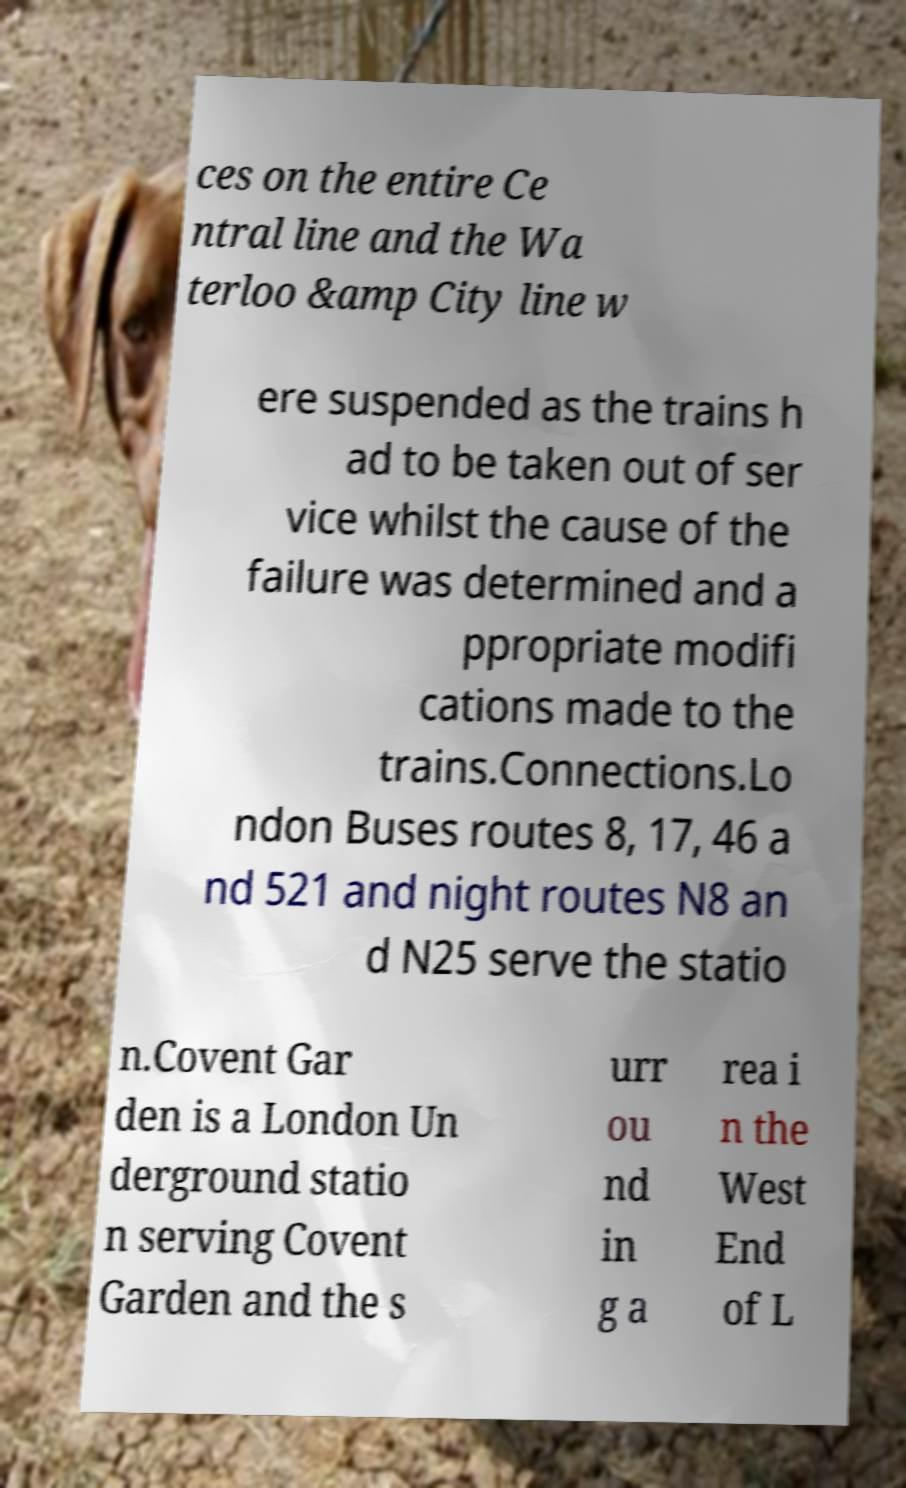Can you accurately transcribe the text from the provided image for me? ces on the entire Ce ntral line and the Wa terloo &amp City line w ere suspended as the trains h ad to be taken out of ser vice whilst the cause of the failure was determined and a ppropriate modifi cations made to the trains.Connections.Lo ndon Buses routes 8, 17, 46 a nd 521 and night routes N8 an d N25 serve the statio n.Covent Gar den is a London Un derground statio n serving Covent Garden and the s urr ou nd in g a rea i n the West End of L 